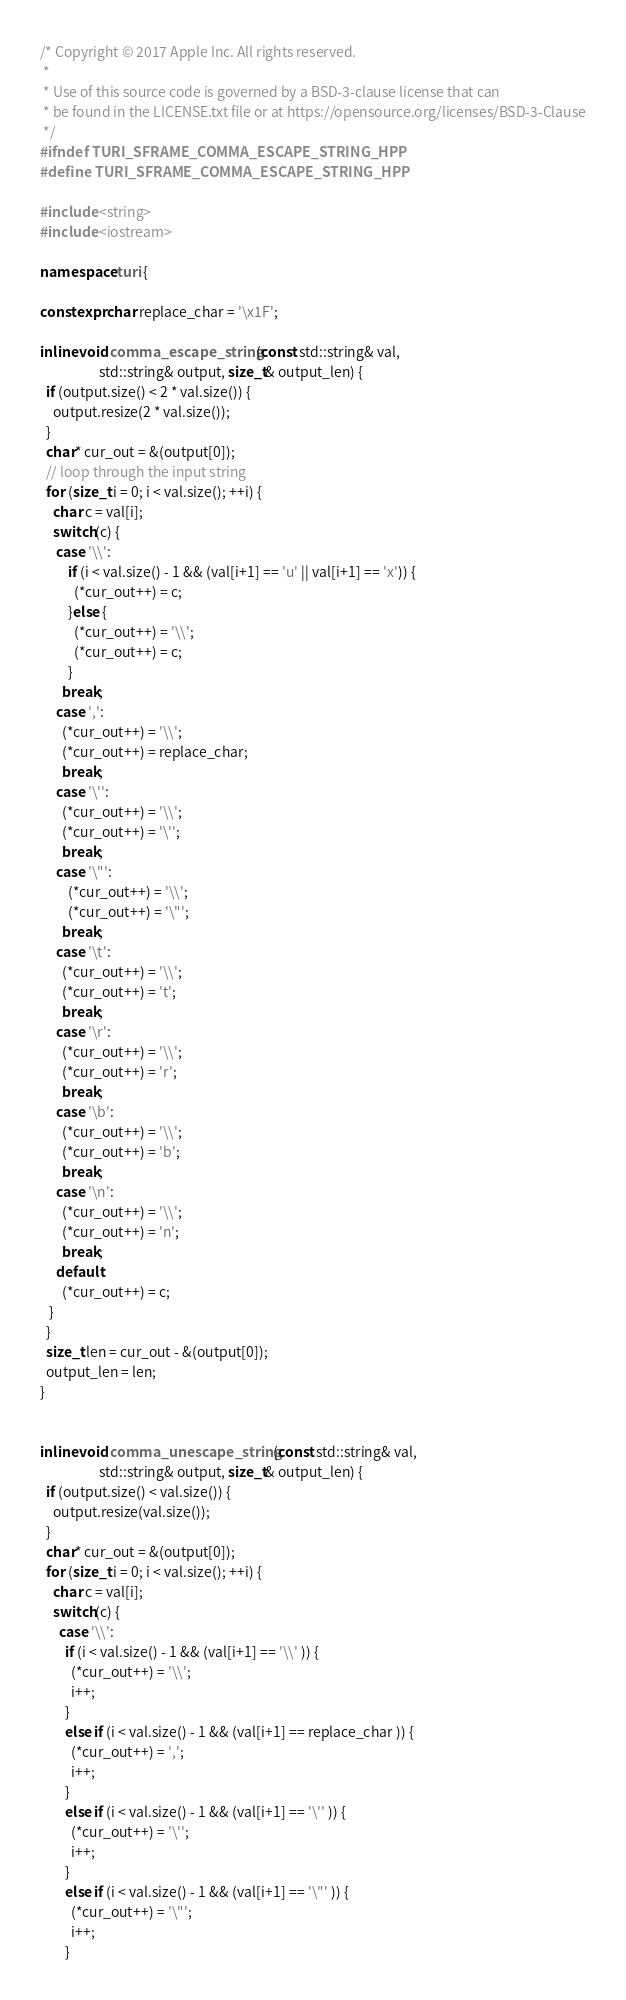Convert code to text. <code><loc_0><loc_0><loc_500><loc_500><_C++_>/* Copyright © 2017 Apple Inc. All rights reserved.
 *
 * Use of this source code is governed by a BSD-3-clause license that can
 * be found in the LICENSE.txt file or at https://opensource.org/licenses/BSD-3-Clause
 */
#ifndef TURI_SFRAME_COMMA_ESCAPE_STRING_HPP
#define TURI_SFRAME_COMMA_ESCAPE_STRING_HPP

#include <string>
#include <iostream>

namespace turi {

constexpr char replace_char = '\x1F';

inline void comma_escape_string(const std::string& val,
                   std::string& output, size_t& output_len) {
  if (output.size() < 2 * val.size()) {
    output.resize(2 * val.size());
  }
  char* cur_out = &(output[0]);
  // loop through the input string
  for (size_t i = 0; i < val.size(); ++i) {
    char c = val[i];
    switch(c) {
     case '\\':
         if (i < val.size() - 1 && (val[i+1] == 'u' || val[i+1] == 'x')) {
           (*cur_out++) = c;
         }else {
           (*cur_out++) = '\\';
           (*cur_out++) = c;
         }
       break;
     case ',':
       (*cur_out++) = '\\';
       (*cur_out++) = replace_char;
       break;
     case '\'':
       (*cur_out++) = '\\';
       (*cur_out++) = '\'';
       break;
     case '\"':
         (*cur_out++) = '\\';
         (*cur_out++) = '\"';
       break;
     case '\t':
       (*cur_out++) = '\\';
       (*cur_out++) = 't';
       break;
     case '\r':
       (*cur_out++) = '\\';
       (*cur_out++) = 'r';
       break;
     case '\b':
       (*cur_out++) = '\\';
       (*cur_out++) = 'b';
       break;
     case '\n':
       (*cur_out++) = '\\';
       (*cur_out++) = 'n';
       break;
     default:
       (*cur_out++) = c;
   }
  }
  size_t len = cur_out - &(output[0]);
  output_len = len;
}


inline void comma_unescape_string(const std::string& val,
                   std::string& output, size_t& output_len) {
  if (output.size() < val.size()) {
    output.resize(val.size());
  }
  char* cur_out = &(output[0]);
  for (size_t i = 0; i < val.size(); ++i) {
    char c = val[i];
    switch(c) {
      case '\\':
        if (i < val.size() - 1 && (val[i+1] == '\\' )) {
          (*cur_out++) = '\\';
          i++;
        }
        else if (i < val.size() - 1 && (val[i+1] == replace_char )) {
          (*cur_out++) = ',';
          i++;
        }
        else if (i < val.size() - 1 && (val[i+1] == '\'' )) {
          (*cur_out++) = '\'';
          i++;
        }
        else if (i < val.size() - 1 && (val[i+1] == '\"' )) {
          (*cur_out++) = '\"';
          i++;
        }</code> 